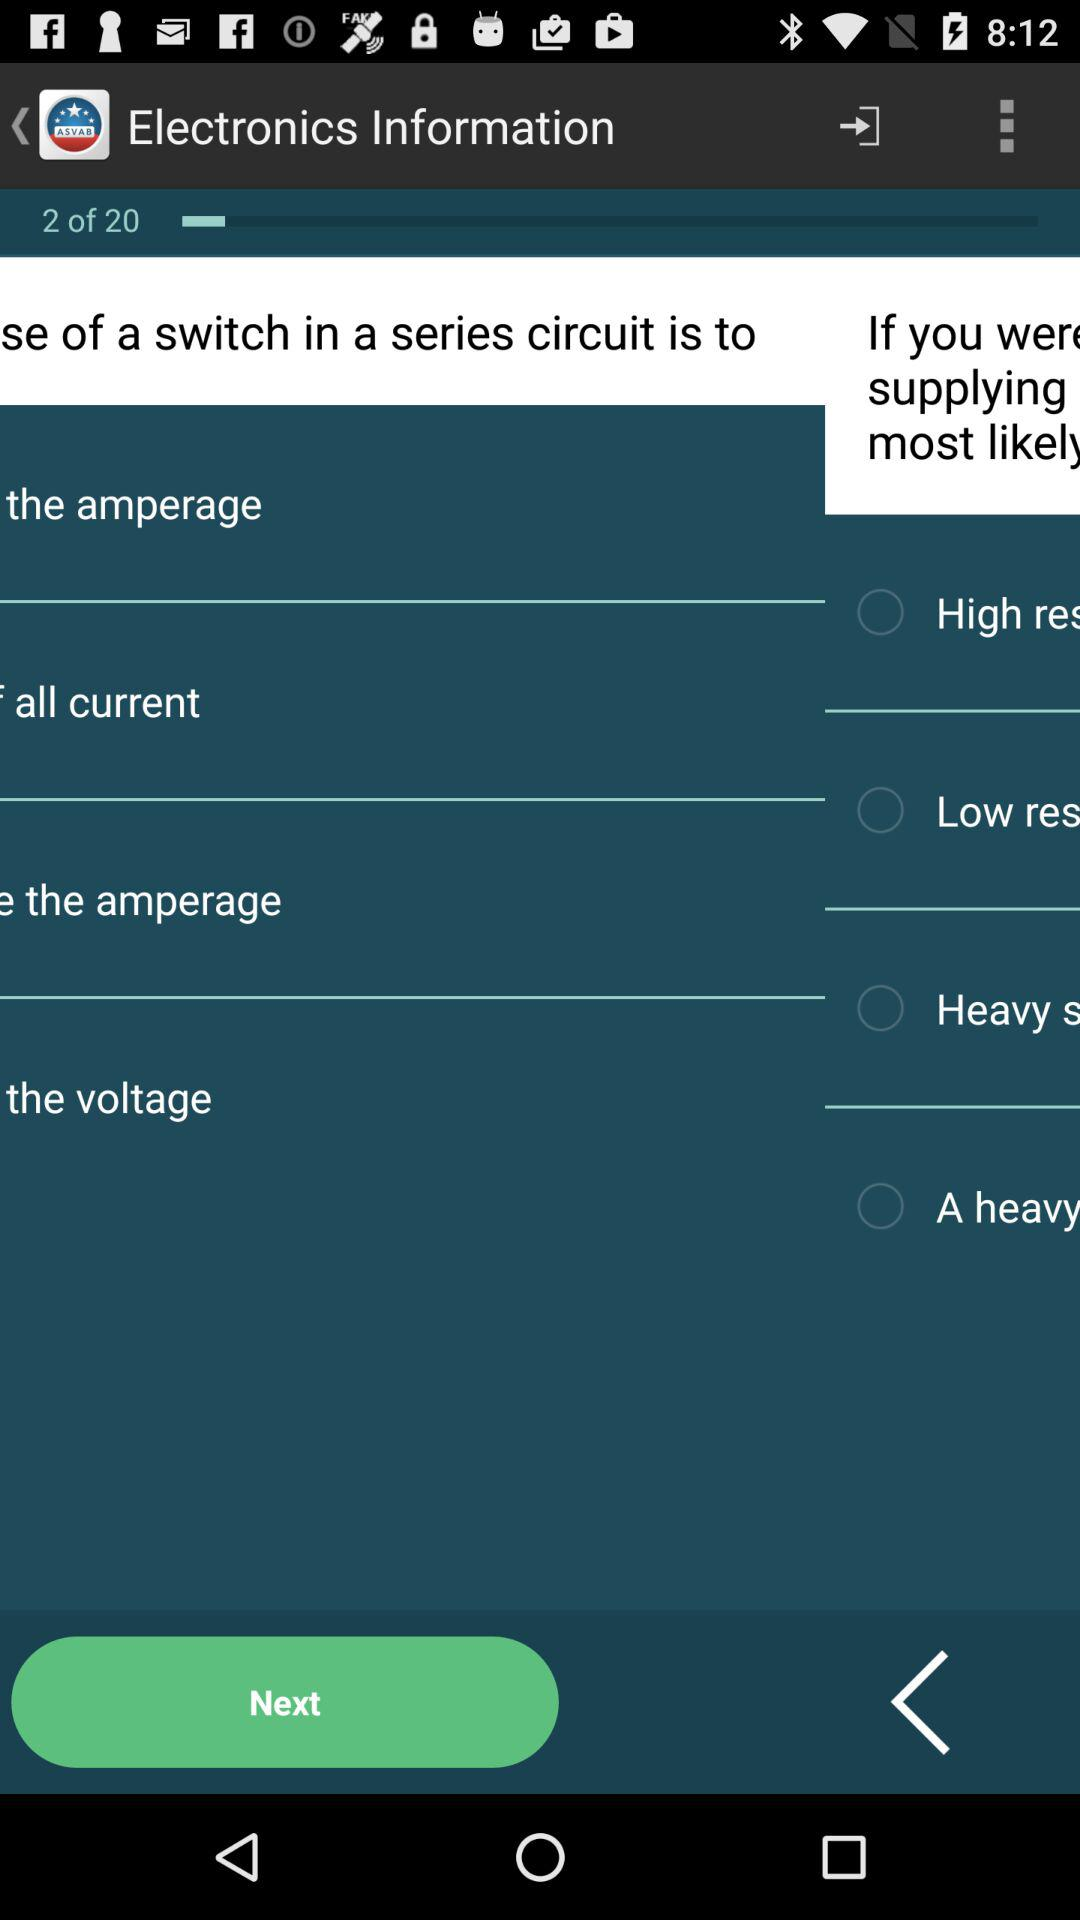How many total pages of "Electronics Information"? The total number of pages of "Electronics Information" is 20. 